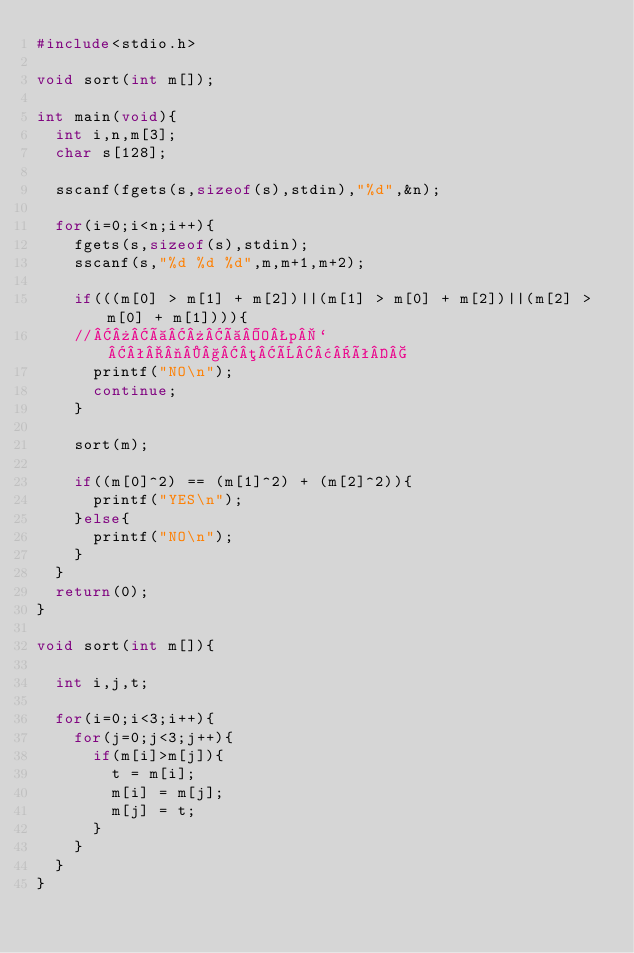Convert code to text. <code><loc_0><loc_0><loc_500><loc_500><_C_>#include<stdio.h>

void sort(int m[]);

int main(void){
	int i,n,m[3];
	char s[128];

	sscanf(fgets(s,sizeof(s),stdin),"%d",&n);

	for(i=0;i<n;i++){
		fgets(s,sizeof(s),stdin);
		sscanf(s,"%d %d %d",m,m+1,m+2);

		if(((m[0] > m[1] + m[2])||(m[1] > m[0] + m[2])||(m[2] > m[0] + m[1]))){
		//»à»àOp`ª¬§µÈ¢ê
			printf("NO\n");
			continue;
		}

		sort(m);

		if((m[0]^2) == (m[1]^2) + (m[2]^2)){
			printf("YES\n");
		}else{
			printf("NO\n");
		}
	}
	return(0);
}

void sort(int m[]){

	int i,j,t;

	for(i=0;i<3;i++){
		for(j=0;j<3;j++){
			if(m[i]>m[j]){
				t = m[i];
				m[i] = m[j];
				m[j] = t;
			}
		}
	}
}</code> 